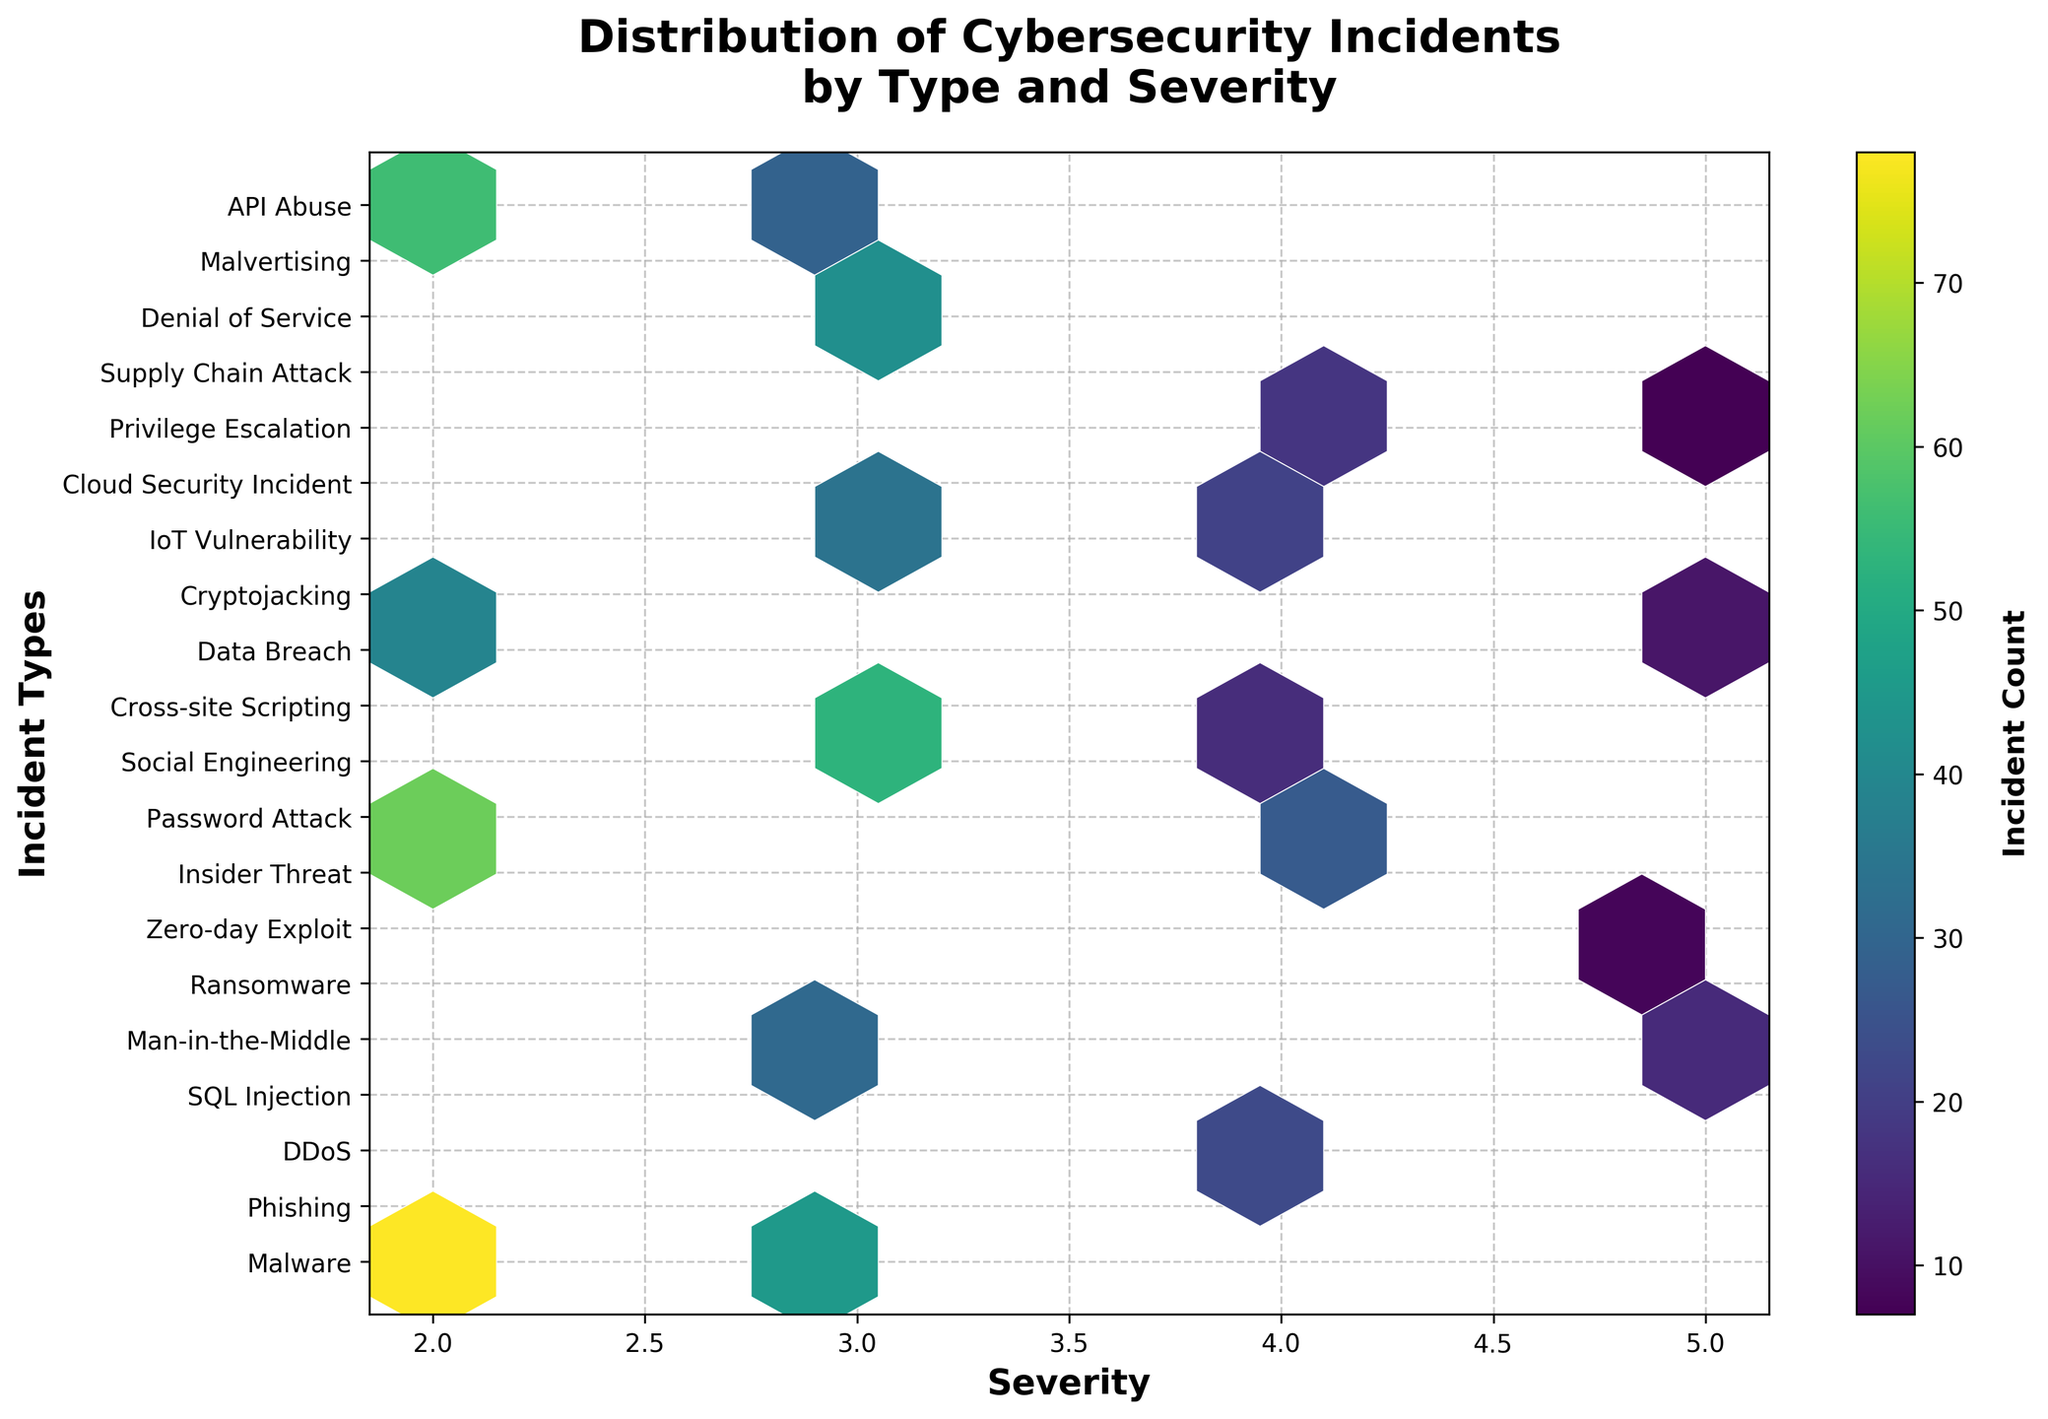What is the title of the plot? The title is displayed at the top of the plot and reads 'Distribution of Cybersecurity Incidents by Type and Severity'.
Answer: Distribution of Cybersecurity Incidents by Type and Severity How are the incident types labeled on the plot? The incident types are labeled along the y-axis as distinct tick marks with names such as 'Malware', 'Phishing', etc.
Answer: Along the y-axis What does the color intensity represent in the plot? The color intensity represents the incident count; the color bar indicates higher counts with darker tones.
Answer: Incident count Which incident severity has the highest number of types associated with it on the plot? By examining the x-axis, severity level 3 has the most types associated with it as it appears most frequently.
Answer: Severity level 3 Which incident type has the highest count at severity level 2? By locating the darkest hexbin at severity level 2, 'Phishing' has the highest count.
Answer: Phishing Compare the incident counts between 'Ransomware' and 'SQL Injection'. Which has a higher count and at which severity levels? 'Ransomware' has a count of 19 at severity 5, while 'SQL Injection' has a count of 12 at severity 5. So, 'Ransomware' has a higher count at severity level 5.
Answer: Ransomware, severity level 5 What is the average count of incidents at severity level 4? Adding counts at severity 4 (23 + 27 + 16 + 21 + 18) = 105. There are 5 types, so the average is 105/5 = 21.
Answer: 21 How many types of incidents have a severity level of 5? Count the number of data points along the x-axis at severity level 5, which are: 'SQL Injection', 'Ransomware', 'Zero-day Exploit', 'Data Breach', and 'Supply Chain Attack'.
Answer: 5 Which incident type has the lowest count, and what is its severity level? Locate the incident type with the lightest colored hexbin. 'Supply Chain Attack' has the lowest count with a count of 7 at severity level 5.
Answer: Supply Chain Attack, severity level 5 Is there a higher concentration of incidents at lower or higher severity levels? Observing the hexbin color density along the x-axis, there is a higher concentration of incidents at lower severity levels (2 and 3).
Answer: Lower severity levels 